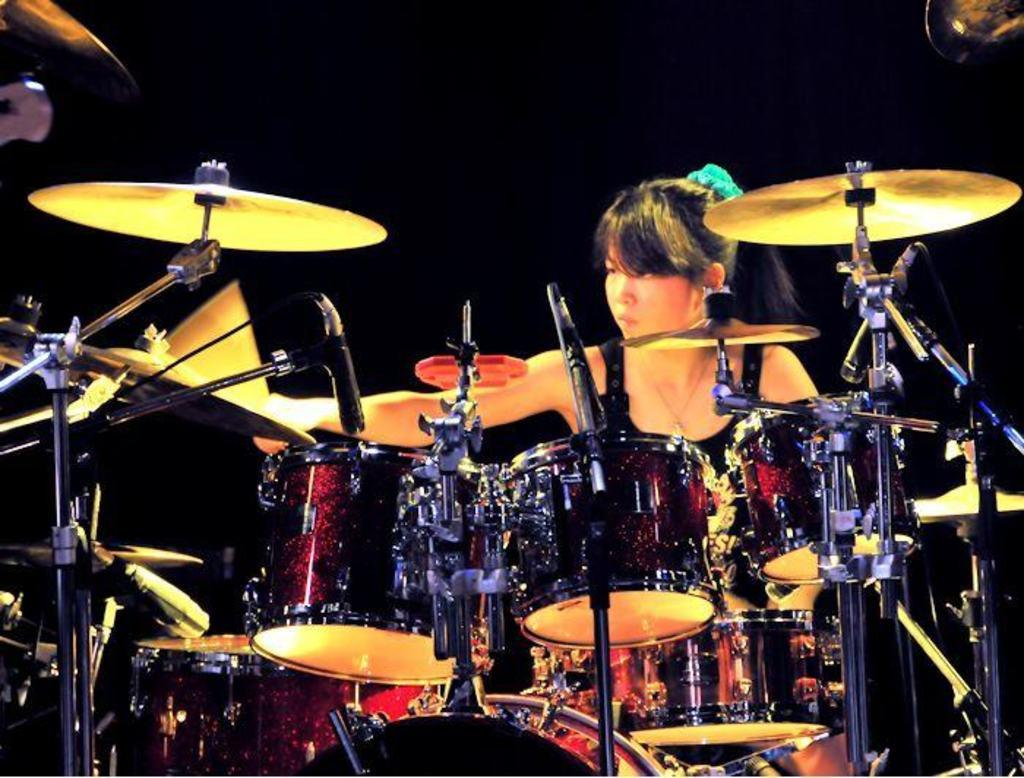What is the woman in the image doing? The woman is playing drums in the image. What instruments can be seen in the image? There are drums and two cymbals in the image. What might be used for amplifying sound in the image? There are microphones in the image. What type of mouthwash is the woman using during the meeting in the image? There is no mouthwash or meeting present in the image; it features a woman playing drums with drums, cymbals, and microphones. 